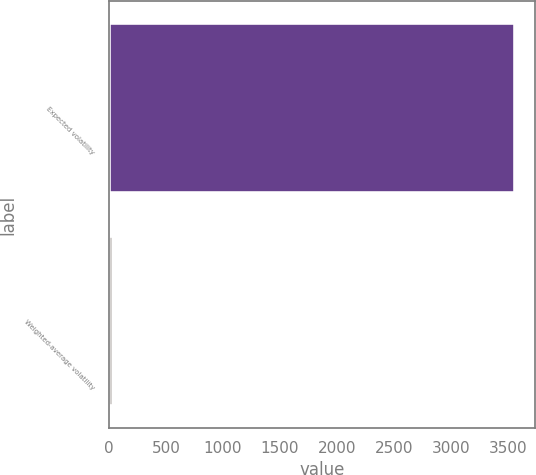<chart> <loc_0><loc_0><loc_500><loc_500><bar_chart><fcel>Expected volatility<fcel>Weighted-average volatility<nl><fcel>3557<fcel>39<nl></chart> 